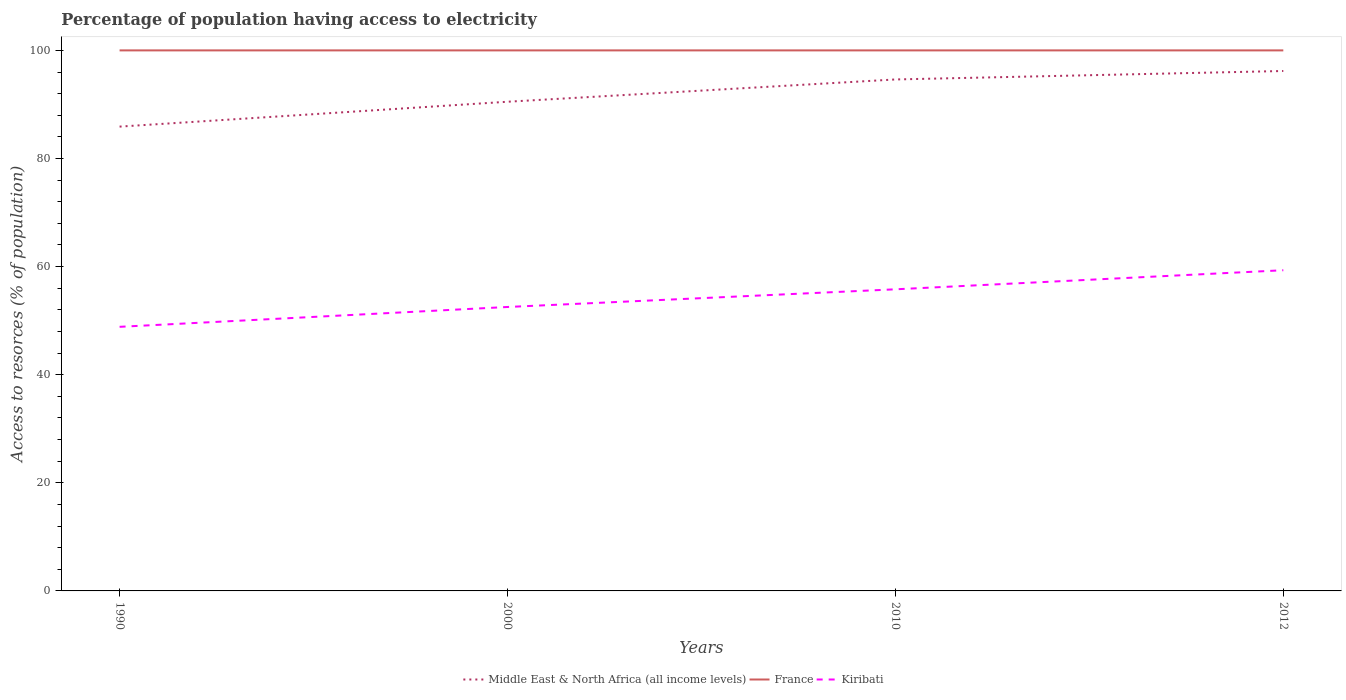How many different coloured lines are there?
Ensure brevity in your answer.  3. Is the number of lines equal to the number of legend labels?
Provide a succinct answer. Yes. Across all years, what is the maximum percentage of population having access to electricity in France?
Provide a short and direct response. 100. What is the total percentage of population having access to electricity in Middle East & North Africa (all income levels) in the graph?
Provide a succinct answer. -5.69. What is the difference between the highest and the second highest percentage of population having access to electricity in Middle East & North Africa (all income levels)?
Your answer should be compact. 10.29. Is the percentage of population having access to electricity in Middle East & North Africa (all income levels) strictly greater than the percentage of population having access to electricity in France over the years?
Provide a succinct answer. Yes. How many lines are there?
Give a very brief answer. 3. Does the graph contain any zero values?
Provide a short and direct response. No. Does the graph contain grids?
Make the answer very short. No. Where does the legend appear in the graph?
Your response must be concise. Bottom center. What is the title of the graph?
Ensure brevity in your answer.  Percentage of population having access to electricity. Does "Curacao" appear as one of the legend labels in the graph?
Make the answer very short. No. What is the label or title of the Y-axis?
Provide a short and direct response. Access to resorces (% of population). What is the Access to resorces (% of population) of Middle East & North Africa (all income levels) in 1990?
Provide a short and direct response. 85.9. What is the Access to resorces (% of population) of Kiribati in 1990?
Give a very brief answer. 48.86. What is the Access to resorces (% of population) of Middle East & North Africa (all income levels) in 2000?
Your answer should be compact. 90.5. What is the Access to resorces (% of population) in France in 2000?
Offer a very short reply. 100. What is the Access to resorces (% of population) in Kiribati in 2000?
Ensure brevity in your answer.  52.53. What is the Access to resorces (% of population) of Middle East & North Africa (all income levels) in 2010?
Your answer should be very brief. 94.62. What is the Access to resorces (% of population) in Kiribati in 2010?
Provide a short and direct response. 55.8. What is the Access to resorces (% of population) of Middle East & North Africa (all income levels) in 2012?
Provide a short and direct response. 96.19. What is the Access to resorces (% of population) in France in 2012?
Give a very brief answer. 100. What is the Access to resorces (% of population) in Kiribati in 2012?
Your answer should be compact. 59.33. Across all years, what is the maximum Access to resorces (% of population) of Middle East & North Africa (all income levels)?
Keep it short and to the point. 96.19. Across all years, what is the maximum Access to resorces (% of population) in France?
Offer a terse response. 100. Across all years, what is the maximum Access to resorces (% of population) in Kiribati?
Your answer should be compact. 59.33. Across all years, what is the minimum Access to resorces (% of population) in Middle East & North Africa (all income levels)?
Your response must be concise. 85.9. Across all years, what is the minimum Access to resorces (% of population) in France?
Provide a succinct answer. 100. Across all years, what is the minimum Access to resorces (% of population) of Kiribati?
Offer a terse response. 48.86. What is the total Access to resorces (% of population) in Middle East & North Africa (all income levels) in the graph?
Give a very brief answer. 367.21. What is the total Access to resorces (% of population) in Kiribati in the graph?
Ensure brevity in your answer.  216.52. What is the difference between the Access to resorces (% of population) of Middle East & North Africa (all income levels) in 1990 and that in 2000?
Your answer should be very brief. -4.6. What is the difference between the Access to resorces (% of population) in Kiribati in 1990 and that in 2000?
Keep it short and to the point. -3.67. What is the difference between the Access to resorces (% of population) in Middle East & North Africa (all income levels) in 1990 and that in 2010?
Your response must be concise. -8.73. What is the difference between the Access to resorces (% of population) of Kiribati in 1990 and that in 2010?
Provide a short and direct response. -6.94. What is the difference between the Access to resorces (% of population) in Middle East & North Africa (all income levels) in 1990 and that in 2012?
Ensure brevity in your answer.  -10.29. What is the difference between the Access to resorces (% of population) in France in 1990 and that in 2012?
Provide a succinct answer. 0. What is the difference between the Access to resorces (% of population) in Kiribati in 1990 and that in 2012?
Your response must be concise. -10.47. What is the difference between the Access to resorces (% of population) of Middle East & North Africa (all income levels) in 2000 and that in 2010?
Your answer should be compact. -4.12. What is the difference between the Access to resorces (% of population) of France in 2000 and that in 2010?
Your answer should be compact. 0. What is the difference between the Access to resorces (% of population) in Kiribati in 2000 and that in 2010?
Keep it short and to the point. -3.27. What is the difference between the Access to resorces (% of population) in Middle East & North Africa (all income levels) in 2000 and that in 2012?
Provide a succinct answer. -5.69. What is the difference between the Access to resorces (% of population) of France in 2000 and that in 2012?
Your response must be concise. 0. What is the difference between the Access to resorces (% of population) in Kiribati in 2000 and that in 2012?
Your response must be concise. -6.8. What is the difference between the Access to resorces (% of population) in Middle East & North Africa (all income levels) in 2010 and that in 2012?
Give a very brief answer. -1.56. What is the difference between the Access to resorces (% of population) in France in 2010 and that in 2012?
Offer a very short reply. 0. What is the difference between the Access to resorces (% of population) in Kiribati in 2010 and that in 2012?
Offer a terse response. -3.53. What is the difference between the Access to resorces (% of population) of Middle East & North Africa (all income levels) in 1990 and the Access to resorces (% of population) of France in 2000?
Your response must be concise. -14.1. What is the difference between the Access to resorces (% of population) of Middle East & North Africa (all income levels) in 1990 and the Access to resorces (% of population) of Kiribati in 2000?
Provide a succinct answer. 33.37. What is the difference between the Access to resorces (% of population) in France in 1990 and the Access to resorces (% of population) in Kiribati in 2000?
Your answer should be very brief. 47.47. What is the difference between the Access to resorces (% of population) of Middle East & North Africa (all income levels) in 1990 and the Access to resorces (% of population) of France in 2010?
Keep it short and to the point. -14.1. What is the difference between the Access to resorces (% of population) in Middle East & North Africa (all income levels) in 1990 and the Access to resorces (% of population) in Kiribati in 2010?
Make the answer very short. 30.1. What is the difference between the Access to resorces (% of population) of France in 1990 and the Access to resorces (% of population) of Kiribati in 2010?
Offer a very short reply. 44.2. What is the difference between the Access to resorces (% of population) in Middle East & North Africa (all income levels) in 1990 and the Access to resorces (% of population) in France in 2012?
Your answer should be very brief. -14.1. What is the difference between the Access to resorces (% of population) of Middle East & North Africa (all income levels) in 1990 and the Access to resorces (% of population) of Kiribati in 2012?
Ensure brevity in your answer.  26.57. What is the difference between the Access to resorces (% of population) in France in 1990 and the Access to resorces (% of population) in Kiribati in 2012?
Give a very brief answer. 40.67. What is the difference between the Access to resorces (% of population) in Middle East & North Africa (all income levels) in 2000 and the Access to resorces (% of population) in France in 2010?
Offer a very short reply. -9.5. What is the difference between the Access to resorces (% of population) in Middle East & North Africa (all income levels) in 2000 and the Access to resorces (% of population) in Kiribati in 2010?
Your response must be concise. 34.7. What is the difference between the Access to resorces (% of population) of France in 2000 and the Access to resorces (% of population) of Kiribati in 2010?
Provide a succinct answer. 44.2. What is the difference between the Access to resorces (% of population) of Middle East & North Africa (all income levels) in 2000 and the Access to resorces (% of population) of France in 2012?
Make the answer very short. -9.5. What is the difference between the Access to resorces (% of population) of Middle East & North Africa (all income levels) in 2000 and the Access to resorces (% of population) of Kiribati in 2012?
Offer a terse response. 31.17. What is the difference between the Access to resorces (% of population) in France in 2000 and the Access to resorces (% of population) in Kiribati in 2012?
Your answer should be very brief. 40.67. What is the difference between the Access to resorces (% of population) in Middle East & North Africa (all income levels) in 2010 and the Access to resorces (% of population) in France in 2012?
Offer a very short reply. -5.38. What is the difference between the Access to resorces (% of population) of Middle East & North Africa (all income levels) in 2010 and the Access to resorces (% of population) of Kiribati in 2012?
Provide a succinct answer. 35.3. What is the difference between the Access to resorces (% of population) in France in 2010 and the Access to resorces (% of population) in Kiribati in 2012?
Your response must be concise. 40.67. What is the average Access to resorces (% of population) in Middle East & North Africa (all income levels) per year?
Keep it short and to the point. 91.8. What is the average Access to resorces (% of population) in France per year?
Provide a succinct answer. 100. What is the average Access to resorces (% of population) in Kiribati per year?
Offer a terse response. 54.13. In the year 1990, what is the difference between the Access to resorces (% of population) in Middle East & North Africa (all income levels) and Access to resorces (% of population) in France?
Keep it short and to the point. -14.1. In the year 1990, what is the difference between the Access to resorces (% of population) in Middle East & North Africa (all income levels) and Access to resorces (% of population) in Kiribati?
Your response must be concise. 37.04. In the year 1990, what is the difference between the Access to resorces (% of population) of France and Access to resorces (% of population) of Kiribati?
Your response must be concise. 51.14. In the year 2000, what is the difference between the Access to resorces (% of population) in Middle East & North Africa (all income levels) and Access to resorces (% of population) in France?
Your answer should be very brief. -9.5. In the year 2000, what is the difference between the Access to resorces (% of population) in Middle East & North Africa (all income levels) and Access to resorces (% of population) in Kiribati?
Keep it short and to the point. 37.97. In the year 2000, what is the difference between the Access to resorces (% of population) in France and Access to resorces (% of population) in Kiribati?
Keep it short and to the point. 47.47. In the year 2010, what is the difference between the Access to resorces (% of population) of Middle East & North Africa (all income levels) and Access to resorces (% of population) of France?
Your answer should be compact. -5.38. In the year 2010, what is the difference between the Access to resorces (% of population) in Middle East & North Africa (all income levels) and Access to resorces (% of population) in Kiribati?
Provide a short and direct response. 38.82. In the year 2010, what is the difference between the Access to resorces (% of population) in France and Access to resorces (% of population) in Kiribati?
Provide a succinct answer. 44.2. In the year 2012, what is the difference between the Access to resorces (% of population) of Middle East & North Africa (all income levels) and Access to resorces (% of population) of France?
Give a very brief answer. -3.81. In the year 2012, what is the difference between the Access to resorces (% of population) of Middle East & North Africa (all income levels) and Access to resorces (% of population) of Kiribati?
Your response must be concise. 36.86. In the year 2012, what is the difference between the Access to resorces (% of population) in France and Access to resorces (% of population) in Kiribati?
Your response must be concise. 40.67. What is the ratio of the Access to resorces (% of population) in Middle East & North Africa (all income levels) in 1990 to that in 2000?
Your answer should be very brief. 0.95. What is the ratio of the Access to resorces (% of population) in France in 1990 to that in 2000?
Your answer should be very brief. 1. What is the ratio of the Access to resorces (% of population) of Kiribati in 1990 to that in 2000?
Your answer should be very brief. 0.93. What is the ratio of the Access to resorces (% of population) of Middle East & North Africa (all income levels) in 1990 to that in 2010?
Keep it short and to the point. 0.91. What is the ratio of the Access to resorces (% of population) of France in 1990 to that in 2010?
Make the answer very short. 1. What is the ratio of the Access to resorces (% of population) of Kiribati in 1990 to that in 2010?
Your answer should be compact. 0.88. What is the ratio of the Access to resorces (% of population) of Middle East & North Africa (all income levels) in 1990 to that in 2012?
Ensure brevity in your answer.  0.89. What is the ratio of the Access to resorces (% of population) of Kiribati in 1990 to that in 2012?
Offer a very short reply. 0.82. What is the ratio of the Access to resorces (% of population) in Middle East & North Africa (all income levels) in 2000 to that in 2010?
Provide a succinct answer. 0.96. What is the ratio of the Access to resorces (% of population) in France in 2000 to that in 2010?
Offer a very short reply. 1. What is the ratio of the Access to resorces (% of population) of Kiribati in 2000 to that in 2010?
Offer a terse response. 0.94. What is the ratio of the Access to resorces (% of population) of Middle East & North Africa (all income levels) in 2000 to that in 2012?
Keep it short and to the point. 0.94. What is the ratio of the Access to resorces (% of population) in Kiribati in 2000 to that in 2012?
Offer a very short reply. 0.89. What is the ratio of the Access to resorces (% of population) in Middle East & North Africa (all income levels) in 2010 to that in 2012?
Provide a succinct answer. 0.98. What is the ratio of the Access to resorces (% of population) of France in 2010 to that in 2012?
Provide a succinct answer. 1. What is the ratio of the Access to resorces (% of population) in Kiribati in 2010 to that in 2012?
Give a very brief answer. 0.94. What is the difference between the highest and the second highest Access to resorces (% of population) of Middle East & North Africa (all income levels)?
Ensure brevity in your answer.  1.56. What is the difference between the highest and the second highest Access to resorces (% of population) in Kiribati?
Offer a very short reply. 3.53. What is the difference between the highest and the lowest Access to resorces (% of population) of Middle East & North Africa (all income levels)?
Provide a succinct answer. 10.29. What is the difference between the highest and the lowest Access to resorces (% of population) of France?
Give a very brief answer. 0. What is the difference between the highest and the lowest Access to resorces (% of population) of Kiribati?
Your answer should be very brief. 10.47. 